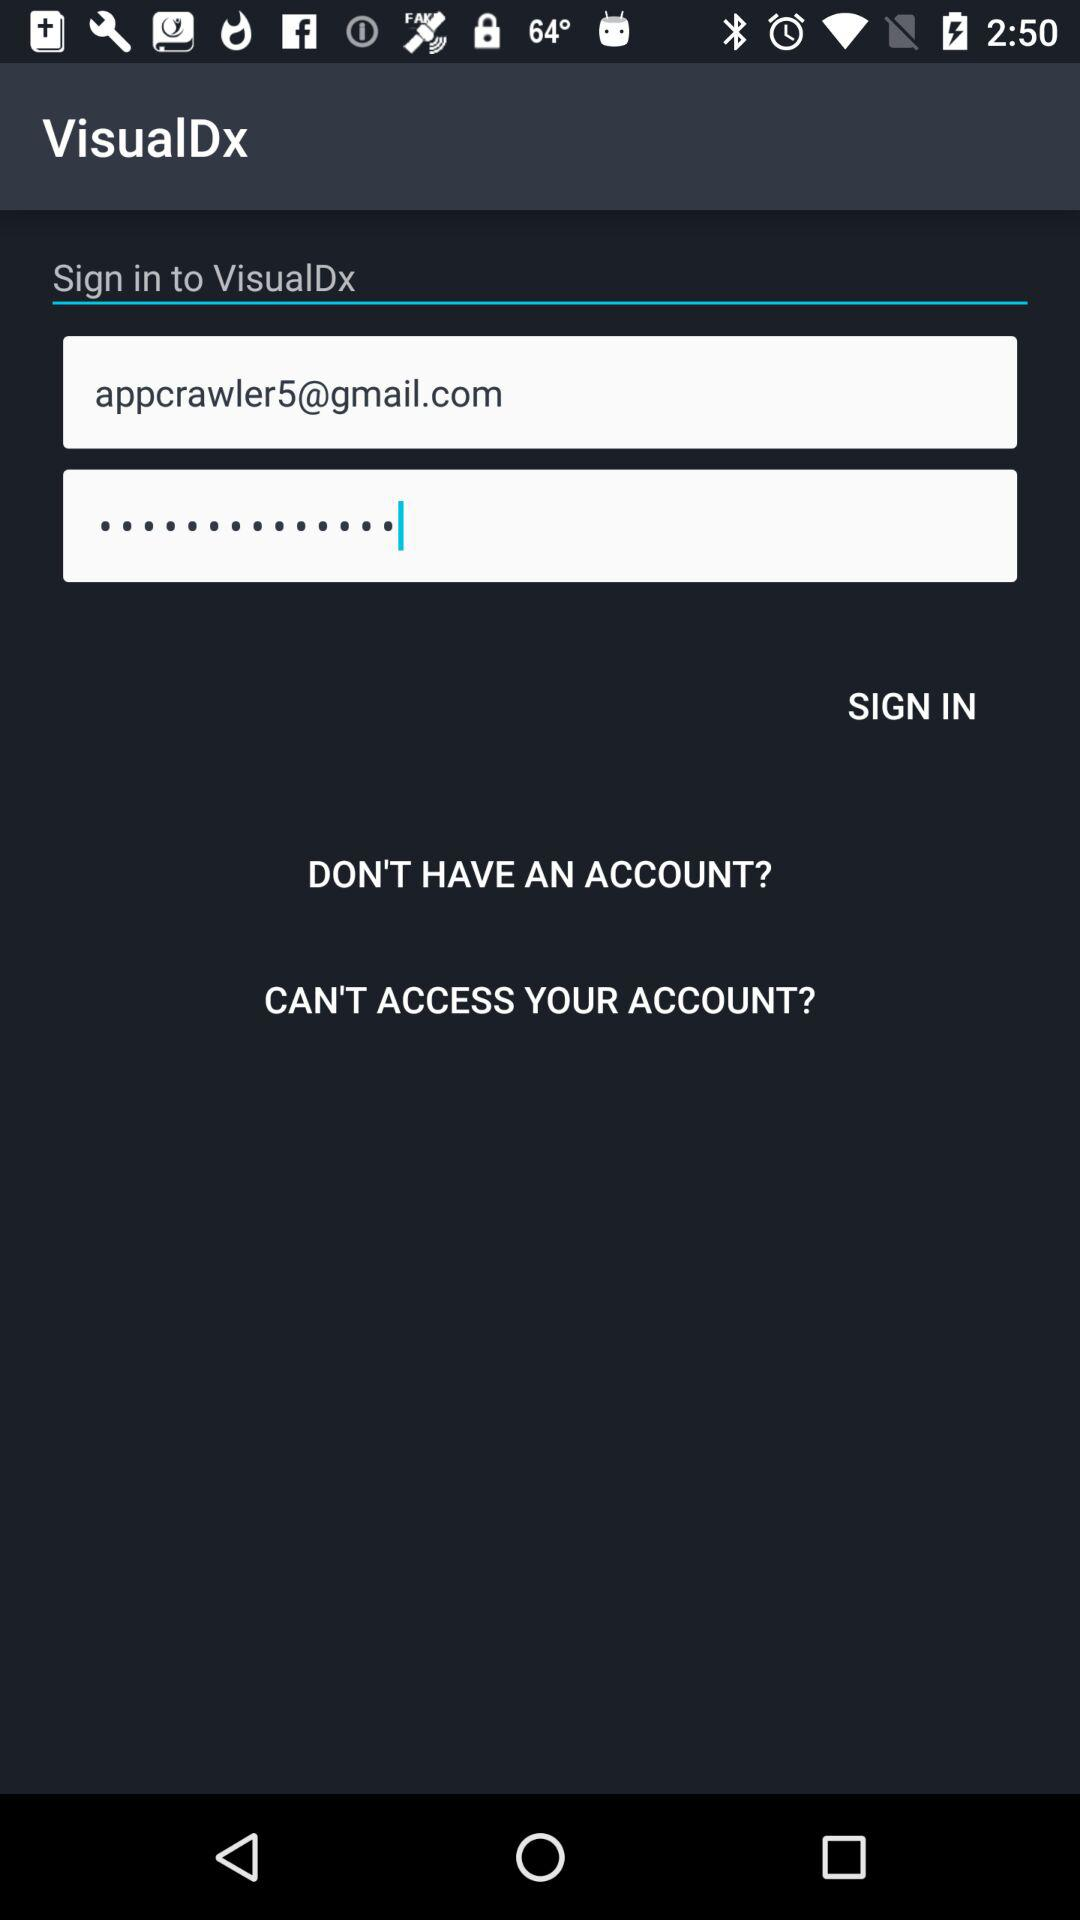What are the requirements to get a login?
When the provided information is insufficient, respond with <no answer>. <no answer> 